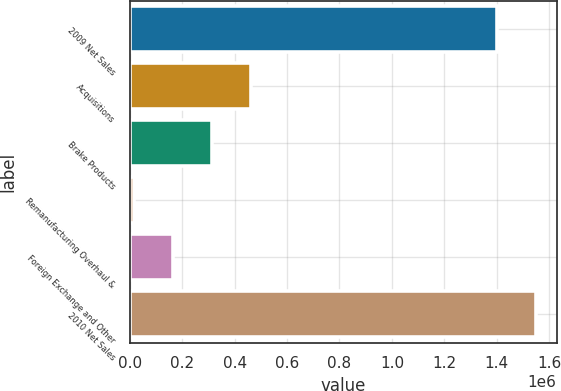Convert chart to OTSL. <chart><loc_0><loc_0><loc_500><loc_500><bar_chart><fcel>2009 Net Sales<fcel>Acquisitions<fcel>Brake Products<fcel>Remanufacturing Overhaul &<fcel>Foreign Exchange and Other<fcel>2010 Net Sales<nl><fcel>1.40162e+06<fcel>463240<fcel>314130<fcel>15909<fcel>165019<fcel>1.55073e+06<nl></chart> 